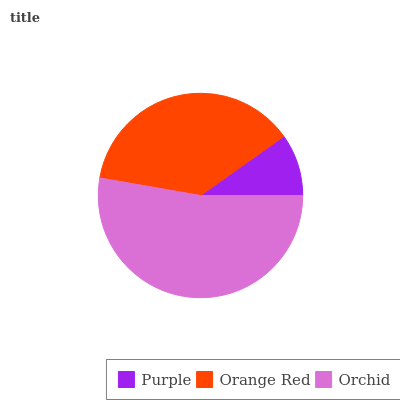Is Purple the minimum?
Answer yes or no. Yes. Is Orchid the maximum?
Answer yes or no. Yes. Is Orange Red the minimum?
Answer yes or no. No. Is Orange Red the maximum?
Answer yes or no. No. Is Orange Red greater than Purple?
Answer yes or no. Yes. Is Purple less than Orange Red?
Answer yes or no. Yes. Is Purple greater than Orange Red?
Answer yes or no. No. Is Orange Red less than Purple?
Answer yes or no. No. Is Orange Red the high median?
Answer yes or no. Yes. Is Orange Red the low median?
Answer yes or no. Yes. Is Orchid the high median?
Answer yes or no. No. Is Orchid the low median?
Answer yes or no. No. 